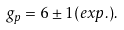<formula> <loc_0><loc_0><loc_500><loc_500>g _ { p } = 6 \pm 1 ( e x p . ) .</formula> 